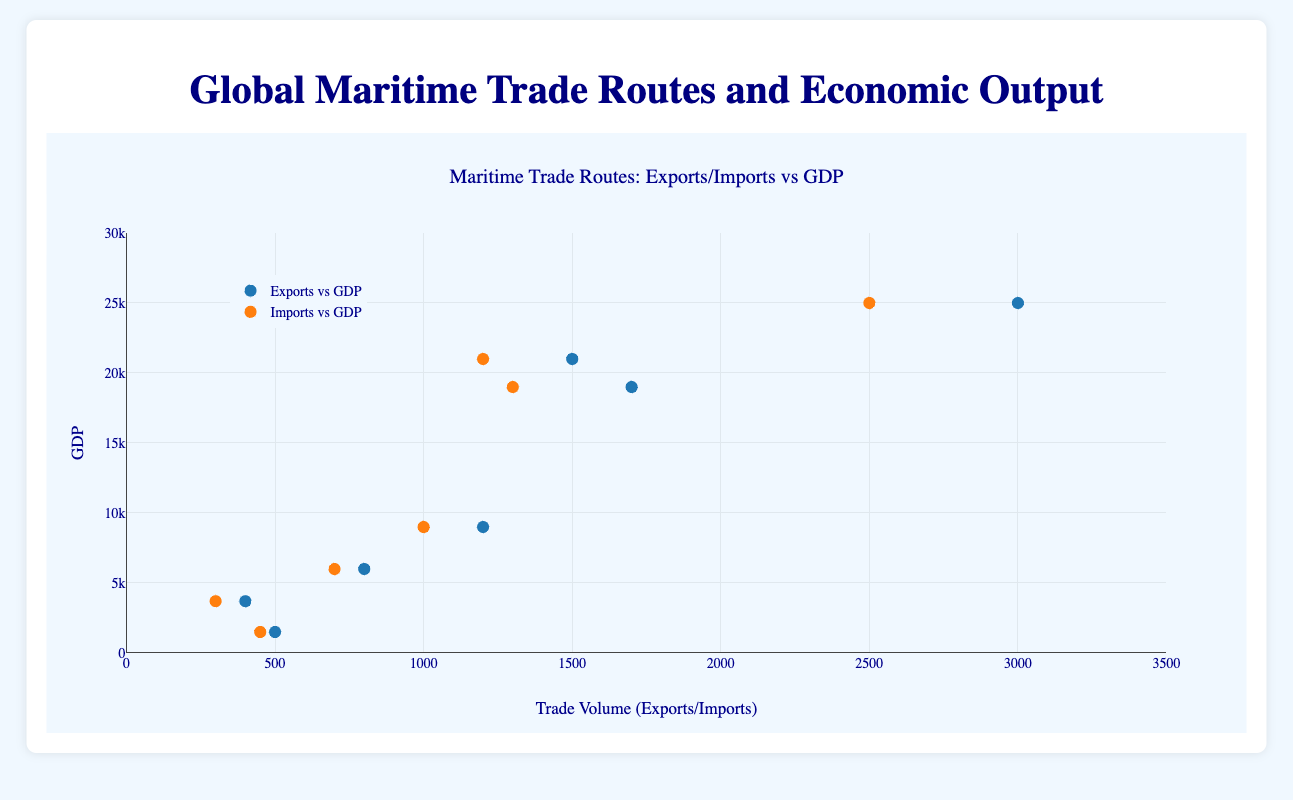What is the title of the figure? The title is displayed at the top of the figure. It reads 'Maritime Trade Routes: Exports/Imports vs GDP'.
Answer: Maritime Trade Routes: Exports/Imports vs GDP What does the x-axis represent? By looking at the x-axis label, we can see it represents 'Trade Volume (Exports/Imports)'.
Answer: Trade Volume (Exports/Imports) How many data points are there for each type of trace (Exports vs GDP and Imports vs GDP)? By examining the figure's legend, we can see the categories. Since each region has one data point for exports and one for imports, and there are 7 regions, there are 7 data points for each trace.
Answer: 7 Which color represents Imports vs GDP? By examining the color associated with "Imports vs GDP" in the legend, we see it is orange.
Answer: Orange What is the range of the y-axis? The y-axis, as labeled, shows values between 0 and 30000.
Answer: 0 to 30000 What is the average GDP for all regions? To find the average GDP, add up the GDPs of all regions (21000+19000+25000+6000+3700+9000+1500) and divide by the number of regions (7).
Sum: 90100
Average: 90100/7
Answer: 12871 What is the difference between the highest Export value and the lowest Export value? To find the difference, identify the maximum and minimum Export values: highest is for Asia (3000), lowest is for Africa (400).
Difference: 3000 - 400
Answer: 2600 Which region's exports correlate with the highest GDP? By identifying the data point with the highest position on the y-axis (GDP) and checking the corresponding x-position (Exports): For Asia (Region), GDP = 25000 and Exports = 3000.
Answer: Asia Which regions have a higher Import volume than Export volume? Compare the import and export values for each region. Asia (2500 > 3000), South America (700 < 800), and Oceania (450 < 500) export more, but all other regions import less or equal amounts than they export (e.g., North America: 1200 < 1500). Answer: None
Answer: None Which has a greater GDP, the region with the highest Imports or the region with the second highest Imports? Identify the region with highest Imports (Asia with 2500) and second highest (Europe with 1300); their GDPs are 25000 and 19000 respectively. Hence, Asia (25000) has a higher GDP than Europe (19000).
Answer: Asia Which trade route is associated with the marker at Exports = 1200 and GDP = 9000? By hovering over the marker or using corresponding data, we find that the trade route for this marker is 'Persian Gulf' belonging to the Middle East region.
Answer: Persian Gulf What information is contained in the hover text for the data point representing Europe? The hover text includes Region: Europe, Trade Route: North Atlantic, Countries: United Kingdom, Germany, France, Exports: 1700, Imports: 1300, and GDP: 19000.
Answer: Region: Europe, Trade Route: North Atlantic, Countries: United Kingdom, Germany, France, Exports: 1700, Imports: 1300, GDP: 19000 